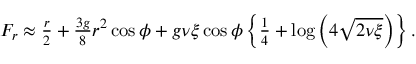Convert formula to latex. <formula><loc_0><loc_0><loc_500><loc_500>\begin{array} { r } { F _ { r } \approx \frac { r } { 2 } + \frac { 3 g } { 8 } r ^ { 2 } \cos \phi + g \nu \xi \cos \phi \left \{ \frac { 1 } { 4 } + \log \left ( 4 \sqrt { 2 \nu \xi } \right ) \right \} . } \end{array}</formula> 